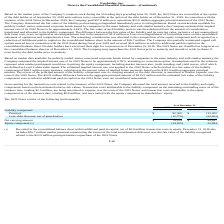According to Everbridge's financial document, What is the net carrying amount in 2019? According to the financial document, $79,224 (in thousands). The relevant text states: "Net carrying amount $ 79,224 $ 94,097..." Also, How much was the market premium at December 31, 2019? According to the financial document, $36.7 million. The relevant text states: "on the consolidated balance sheet in the amount of $36.7 million. The Company also partially terminated capped call options entered into in connection with the 2022..." Also, What does market premium of $36.7 million represent? the excess of the total consideration delivered over the fair value of the liability recognized related to the $23.0 million principal balance repurchase of the 2022 Notes.. The document states: "includes $36.7 million market premium representing the excess of the total consideration delivered over the fair value of the liability recognized rel..." Also, can you calculate: What is the change in Principal from December 31, 2019 to December 31, 2018? Based on the calculation: 92,000-115,000, the result is -23000 (in thousands). This is based on the information: "Principal $ 92,000 $ 115,000 Principal $ 92,000 $ 115,000..." The key data points involved are: 115,000, 92,000. Also, can you calculate: What is the change in the debt discount, net of amortization from December 31, 2019 to December 31, 2018? Based on the calculation: 12,776-20,903, the result is -8127 (in thousands). This is based on the information: "ess: debt discount, net of amortization (12,776) (20,903) Less: debt discount, net of amortization (12,776) (20,903)..." The key data points involved are: 12,776, 20,903. Also, can you calculate: What is the change in Net carrying amount from December 31, 2019 to December 31, 2018? Based on the calculation: 79,224-94,097, the result is -14873 (in thousands). This is based on the information: "Net carrying amount $ 79,224 $ 94,097 Net carrying amount $ 79,224 $ 94,097..." The key data points involved are: 79,224, 94,097. 